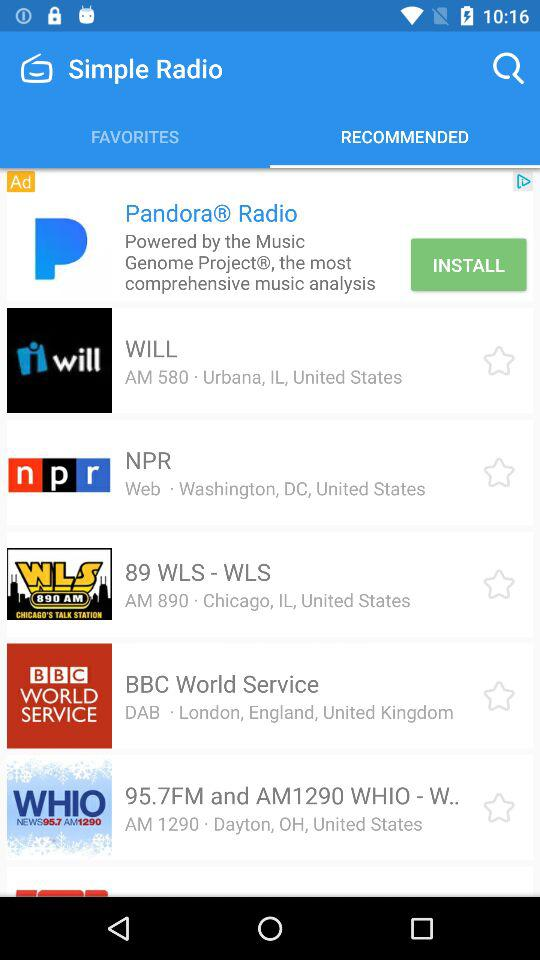What is the location of WILL? The location of WILL is "AM 580, Urbana, IL, United States". 